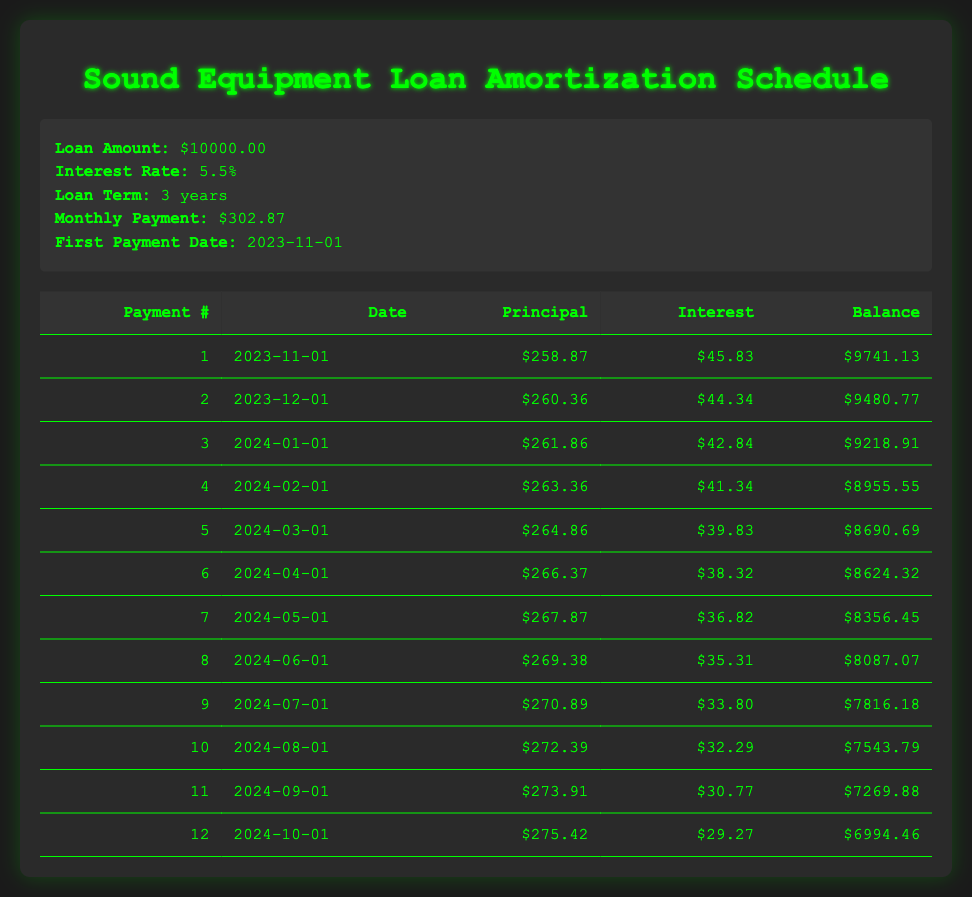What is the total loan amount? The loan amount is explicitly stated in the loan details section as 10000.
Answer: 10000 How much will be paid towards interest on the third payment date? According to the table, the interest payment for the third payment on 2024-01-01 is shown as 42.84.
Answer: 42.84 What will be the remaining balance after the fifth payment? The remaining balance after the fifth payment, as shown in the table for payment number 5, is 8690.69.
Answer: 8690.69 What is the average principal payment across the first 12 months? To find the average principal payment, add all the principal payments from payments 1 to 12: 258.87 + 260.36 + 261.86 + 263.36 + 264.86 + 266.37 + 267.87 + 269.38 + 270.89 + 272.39 + 273.91 + 275.42 =  3238.71. Dividing this sum by 12 gives 269.89.
Answer: 269.89 Is the interest payment for the last month higher than the interest payment for the first month? The interest payment for the last month (29.27) is lower than the interest payment for the first month (45.83) when comparing the two values from the table.
Answer: No What change occurs in the total interest paid by the second payment compared to the first payment? The interest payment for the first payment is 45.83, while for the second payment it is 44.34. The difference is calculated as 45.83 - 44.34 = 1.49, indicating that the interest paid decreased by 1.49.
Answer: 1.49 What is the total amount paid towards the principal after the first six payments? To find the total principal paid after the first six payments, sum the principal payments: 258.87 + 260.36 + 261.86 + 263.36 + 264.86 + 266.37 =  1295.71.
Answer: 1295.71 Is the principal payment of the seventh month greater than the average principal payment from the first six months? The principal payment in the seventh month is 267.87, and the average of the first six is 258.87+260.36+261.86+263.36+264.86+266.37 = 1295.71/6 = 215.95. Since 267.87 > 215.95, the answer is yes.
Answer: Yes How much is left to pay after the sixth payment? The remaining balance after the sixth payment in the amortization table is stated explicitly as 8624.32.
Answer: 8624.32 